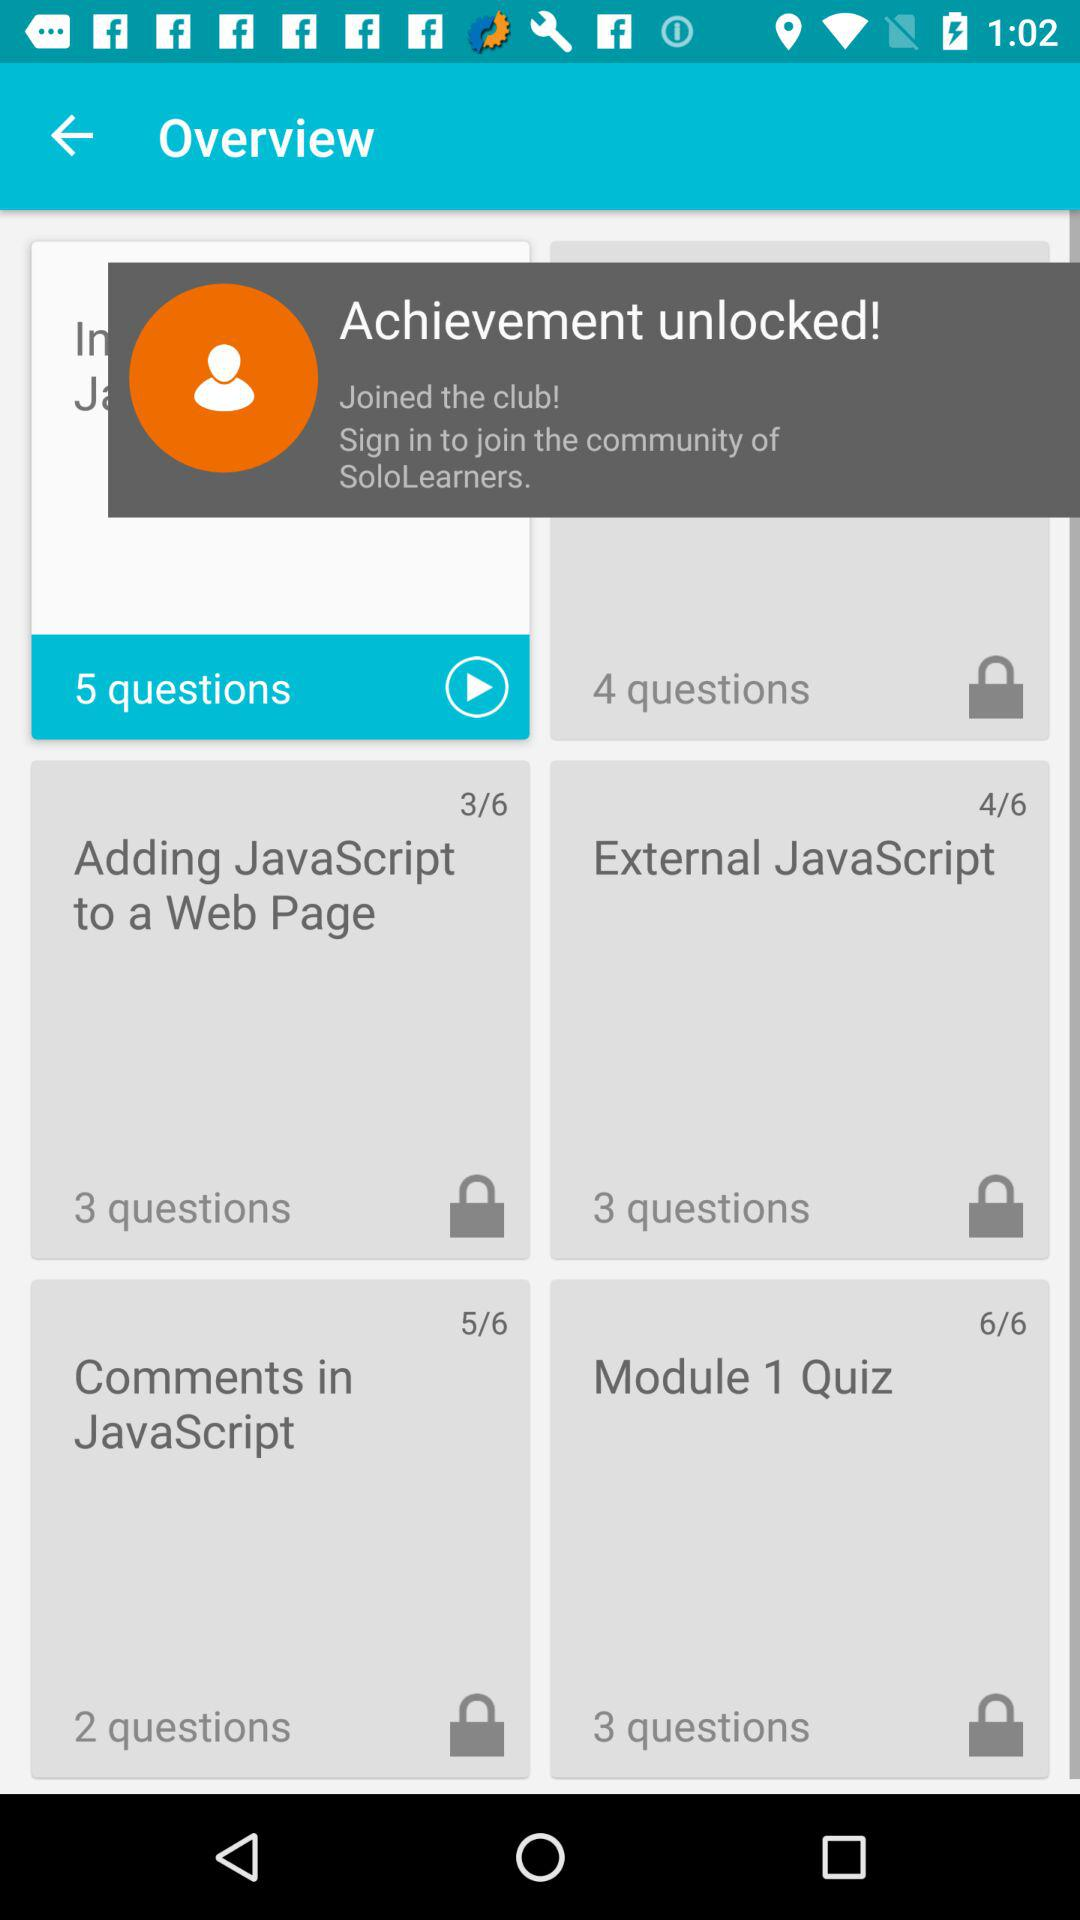What is the total number of steps in external javascript?
When the provided information is insufficient, respond with <no answer>. <no answer> 